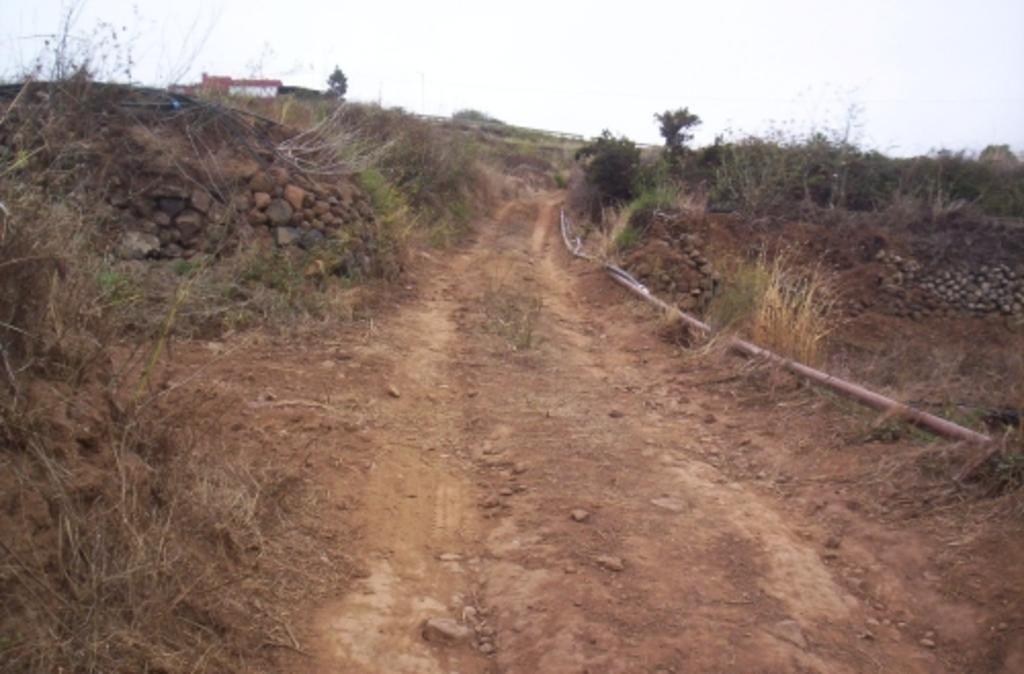What type of vegetation can be seen in the image? There are plants, grass, and trees in the image. What type of ground surface is visible in the image? There are stones in the image. What type of structure is present in the image? There is a building in the image. What is visible at the top of the image? The sky is visible at the top of the image. What type of pest can be seen crawling on the building in the image? There is no pest visible in the image; the building appears to be pest-free. What shape is the grass in the image? The shape of the grass cannot be determined from the image, as it is not a specific shape but rather a natural growth. 